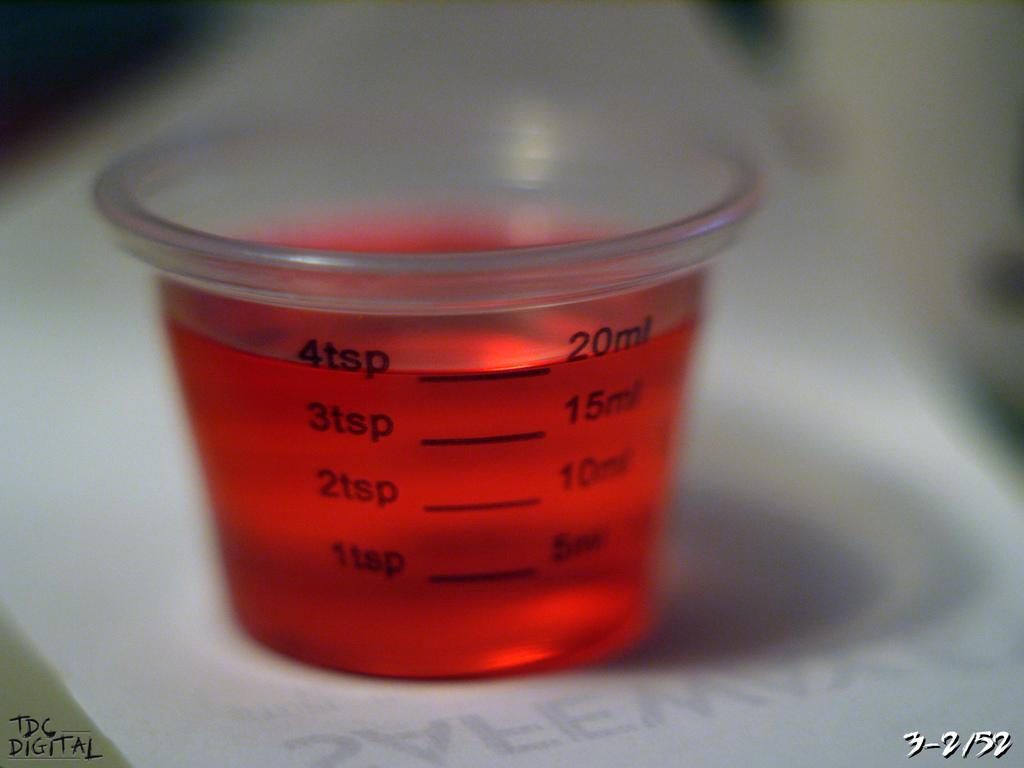<image>
Offer a succinct explanation of the picture presented. The medicine cup contains 4 teaspoons of red syrup. 